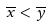<formula> <loc_0><loc_0><loc_500><loc_500>\overline { x } < \overline { y }</formula> 